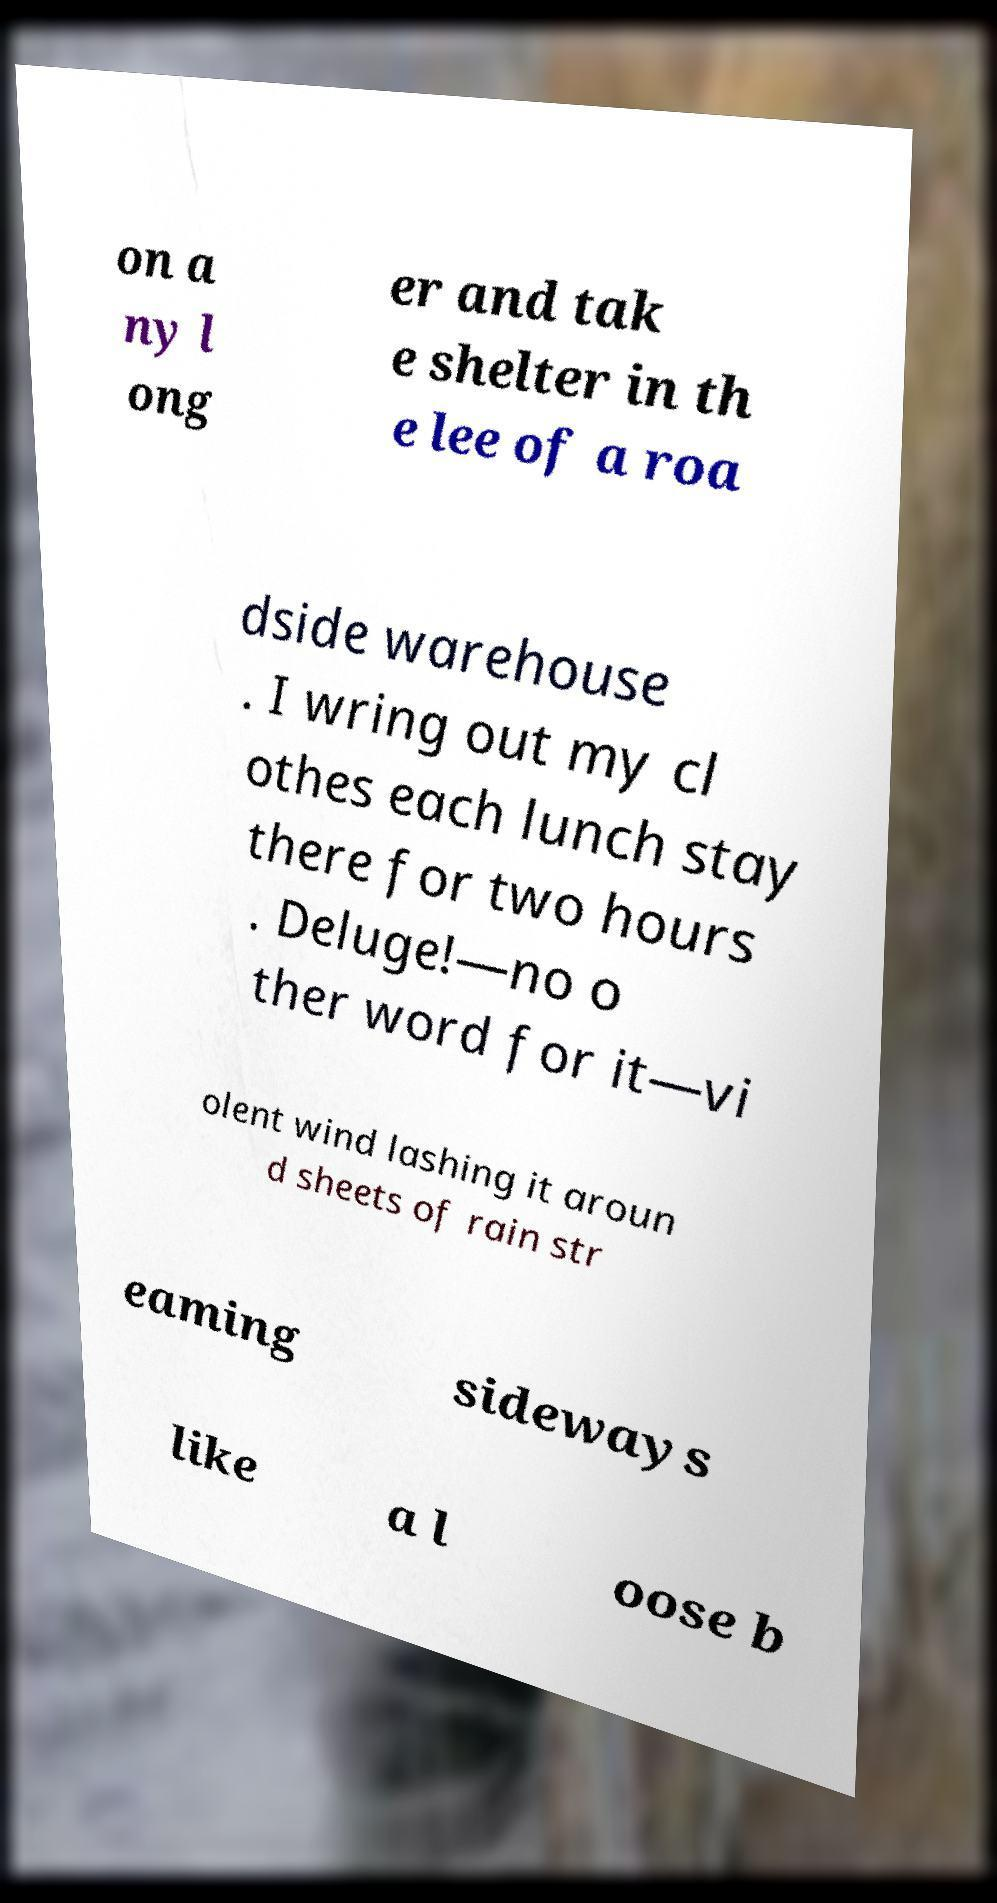There's text embedded in this image that I need extracted. Can you transcribe it verbatim? on a ny l ong er and tak e shelter in th e lee of a roa dside warehouse . I wring out my cl othes each lunch stay there for two hours . Deluge!—no o ther word for it—vi olent wind lashing it aroun d sheets of rain str eaming sideways like a l oose b 